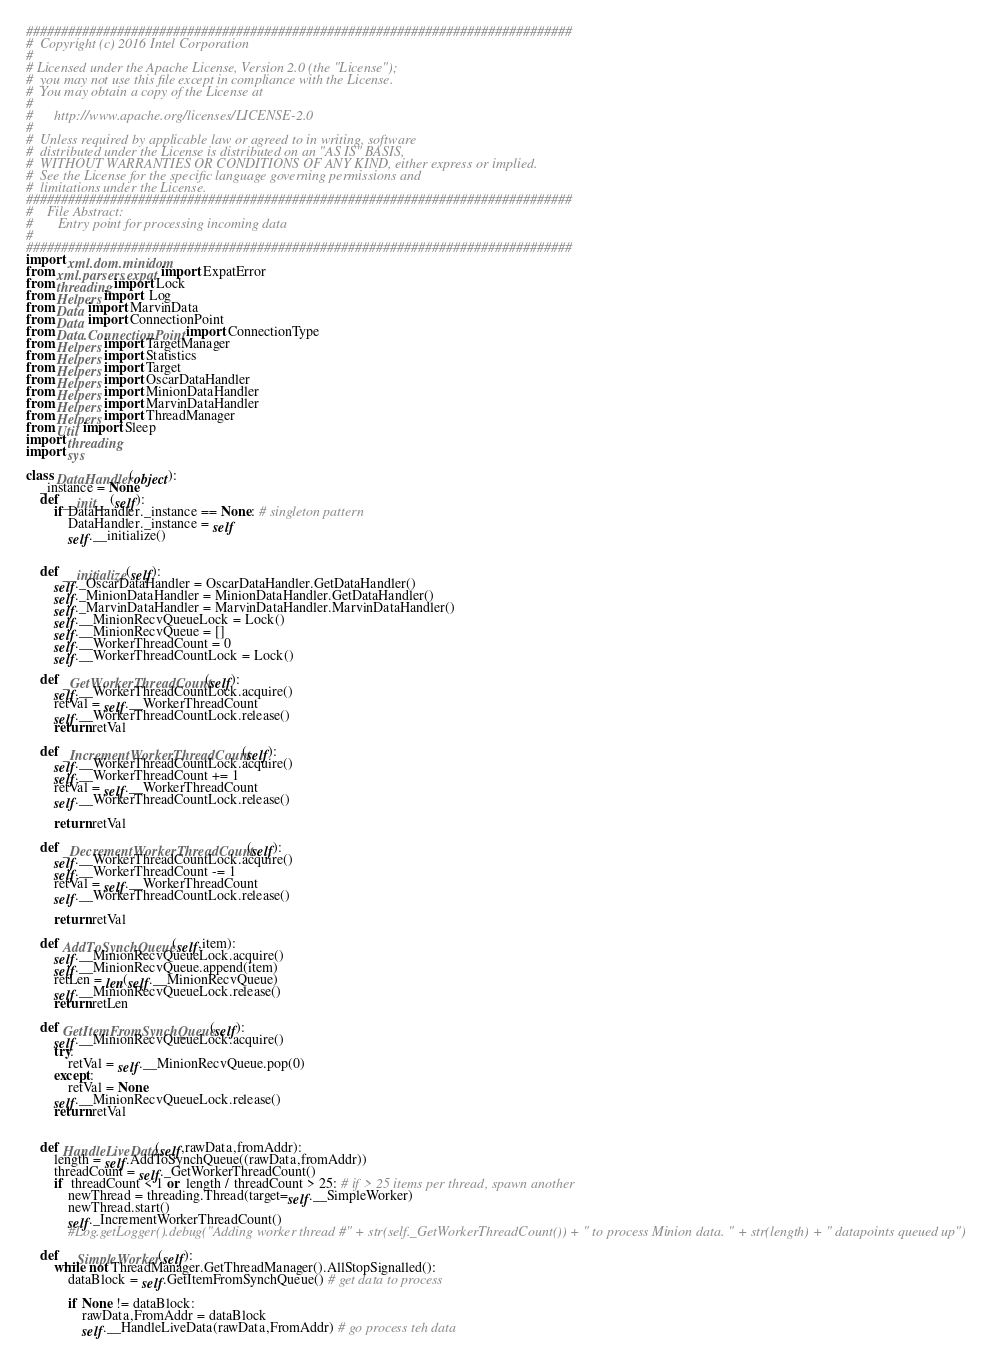<code> <loc_0><loc_0><loc_500><loc_500><_Python_>##############################################################################
#  Copyright (c) 2016 Intel Corporation
# 
# Licensed under the Apache License, Version 2.0 (the "License");
#  you may not use this file except in compliance with the License.
#  You may obtain a copy of the License at
# 
#      http://www.apache.org/licenses/LICENSE-2.0
# 
#  Unless required by applicable law or agreed to in writing, software
#  distributed under the License is distributed on an "AS IS" BASIS,
#  WITHOUT WARRANTIES OR CONDITIONS OF ANY KIND, either express or implied.
#  See the License for the specific language governing permissions and
#  limitations under the License.
##############################################################################
#    File Abstract: 
#       Entry point for processing incoming data
#
##############################################################################
import xml.dom.minidom
from xml.parsers.expat import ExpatError
from threading import Lock
from Helpers import  Log
from Data import MarvinData
from Data import ConnectionPoint
from Data.ConnectionPoint import ConnectionType
from Helpers import TargetManager
from Helpers import Statistics
from Helpers import Target
from Helpers import OscarDataHandler
from Helpers import MinionDataHandler
from Helpers import MarvinDataHandler
from Helpers import ThreadManager
from Util import Sleep
import threading
import sys

class DataHandler(object):
    _instance = None
    def __init__(self):
        if DataHandler._instance == None: # singleton pattern
            DataHandler._instance = self
            self.__initialize()
            

    def __initialize(self):
        self._OscarDataHandler = OscarDataHandler.GetDataHandler()
        self._MinionDataHandler = MinionDataHandler.GetDataHandler()
        self._MarvinDataHandler = MarvinDataHandler.MarvinDataHandler()
        self.__MinionRecvQueueLock = Lock()
        self.__MinionRecvQueue = []
        self.__WorkerThreadCount = 0
        self.__WorkerThreadCountLock = Lock()

    def _GetWorkerThreadCount(self):
        self.__WorkerThreadCountLock.acquire()
        retVal = self.__WorkerThreadCount
        self.__WorkerThreadCountLock.release()
        return retVal

    def _IncrementWorkerThreadCount(self):
        self.__WorkerThreadCountLock.acquire()
        self.__WorkerThreadCount += 1
        retVal = self.__WorkerThreadCount
        self.__WorkerThreadCountLock.release()

        return retVal

    def _DecrementWorkerThreadCount(self):
        self.__WorkerThreadCountLock.acquire()
        self.__WorkerThreadCount -= 1
        retVal = self.__WorkerThreadCount
        self.__WorkerThreadCountLock.release()

        return retVal

    def AddToSynchQueue(self,item):
        self.__MinionRecvQueueLock.acquire()
        self.__MinionRecvQueue.append(item)
        retLen = len(self.__MinionRecvQueue)
        self.__MinionRecvQueueLock.release()
        return retLen

    def GetItemFromSynchQueue(self):
        self.__MinionRecvQueueLock.acquire()
        try:
            retVal = self.__MinionRecvQueue.pop(0)
        except:
            retVal = None
        self.__MinionRecvQueueLock.release()
        return retVal


    def HandleLiveData(self,rawData,fromAddr):
        length = self.AddToSynchQueue((rawData,fromAddr))
        threadCount = self._GetWorkerThreadCount()
        if  threadCount < 1 or  length / threadCount > 25: # if > 25 items per thread, spawn another
            newThread = threading.Thread(target=self.__SimpleWorker)
            newThread.start()
            self._IncrementWorkerThreadCount()
            #Log.getLogger().debug("Adding worker thread #" + str(self._GetWorkerThreadCount()) + " to process Minion data. " + str(length) + " datapoints queued up")

    def __SimpleWorker(self):
        while not ThreadManager.GetThreadManager().AllStopSignalled():
            dataBlock = self.GetItemFromSynchQueue() # get data to process

            if None != dataBlock:
                rawData,FromAddr = dataBlock
                self.__HandleLiveData(rawData,FromAddr) # go process teh data</code> 